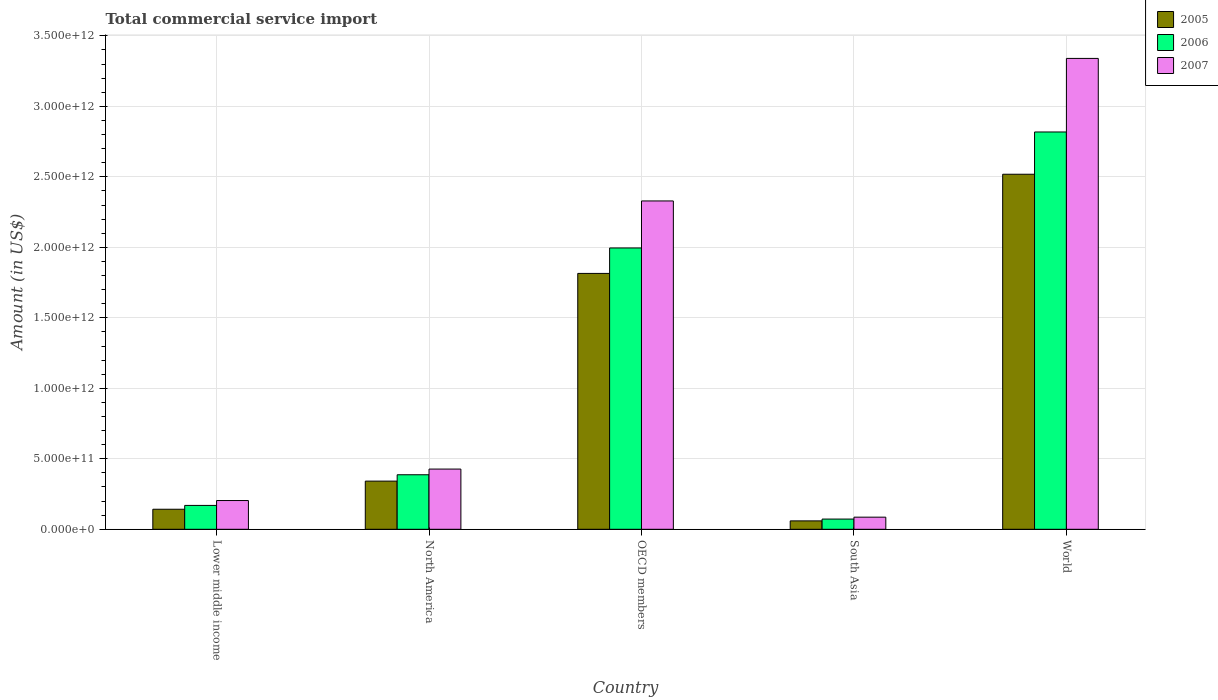Are the number of bars per tick equal to the number of legend labels?
Your response must be concise. Yes. How many bars are there on the 2nd tick from the left?
Give a very brief answer. 3. How many bars are there on the 1st tick from the right?
Offer a terse response. 3. What is the label of the 3rd group of bars from the left?
Ensure brevity in your answer.  OECD members. What is the total commercial service import in 2006 in South Asia?
Provide a short and direct response. 7.25e+1. Across all countries, what is the maximum total commercial service import in 2006?
Your response must be concise. 2.82e+12. Across all countries, what is the minimum total commercial service import in 2005?
Provide a succinct answer. 5.96e+1. What is the total total commercial service import in 2007 in the graph?
Your answer should be very brief. 6.39e+12. What is the difference between the total commercial service import in 2006 in Lower middle income and that in World?
Provide a short and direct response. -2.65e+12. What is the difference between the total commercial service import in 2006 in North America and the total commercial service import in 2005 in Lower middle income?
Offer a very short reply. 2.45e+11. What is the average total commercial service import in 2007 per country?
Offer a very short reply. 1.28e+12. What is the difference between the total commercial service import of/in 2005 and total commercial service import of/in 2007 in World?
Provide a succinct answer. -8.22e+11. In how many countries, is the total commercial service import in 2005 greater than 1300000000000 US$?
Your answer should be compact. 2. What is the ratio of the total commercial service import in 2006 in Lower middle income to that in World?
Your answer should be compact. 0.06. What is the difference between the highest and the second highest total commercial service import in 2006?
Your answer should be compact. 8.23e+11. What is the difference between the highest and the lowest total commercial service import in 2007?
Offer a very short reply. 3.25e+12. What does the 1st bar from the left in Lower middle income represents?
Your answer should be very brief. 2005. Is it the case that in every country, the sum of the total commercial service import in 2005 and total commercial service import in 2007 is greater than the total commercial service import in 2006?
Make the answer very short. Yes. What is the difference between two consecutive major ticks on the Y-axis?
Your response must be concise. 5.00e+11. Does the graph contain grids?
Ensure brevity in your answer.  Yes. How are the legend labels stacked?
Provide a short and direct response. Vertical. What is the title of the graph?
Offer a very short reply. Total commercial service import. Does "1996" appear as one of the legend labels in the graph?
Your response must be concise. No. What is the label or title of the Y-axis?
Offer a terse response. Amount (in US$). What is the Amount (in US$) of 2005 in Lower middle income?
Your answer should be very brief. 1.42e+11. What is the Amount (in US$) in 2006 in Lower middle income?
Make the answer very short. 1.69e+11. What is the Amount (in US$) in 2007 in Lower middle income?
Your answer should be compact. 2.04e+11. What is the Amount (in US$) in 2005 in North America?
Provide a short and direct response. 3.42e+11. What is the Amount (in US$) in 2006 in North America?
Keep it short and to the point. 3.87e+11. What is the Amount (in US$) of 2007 in North America?
Your response must be concise. 4.27e+11. What is the Amount (in US$) in 2005 in OECD members?
Offer a very short reply. 1.81e+12. What is the Amount (in US$) of 2006 in OECD members?
Offer a very short reply. 2.00e+12. What is the Amount (in US$) of 2007 in OECD members?
Offer a terse response. 2.33e+12. What is the Amount (in US$) in 2005 in South Asia?
Your answer should be very brief. 5.96e+1. What is the Amount (in US$) in 2006 in South Asia?
Ensure brevity in your answer.  7.25e+1. What is the Amount (in US$) in 2007 in South Asia?
Ensure brevity in your answer.  8.60e+1. What is the Amount (in US$) in 2005 in World?
Offer a terse response. 2.52e+12. What is the Amount (in US$) of 2006 in World?
Provide a succinct answer. 2.82e+12. What is the Amount (in US$) of 2007 in World?
Provide a succinct answer. 3.34e+12. Across all countries, what is the maximum Amount (in US$) in 2005?
Your answer should be very brief. 2.52e+12. Across all countries, what is the maximum Amount (in US$) in 2006?
Keep it short and to the point. 2.82e+12. Across all countries, what is the maximum Amount (in US$) in 2007?
Offer a very short reply. 3.34e+12. Across all countries, what is the minimum Amount (in US$) of 2005?
Your answer should be compact. 5.96e+1. Across all countries, what is the minimum Amount (in US$) in 2006?
Your response must be concise. 7.25e+1. Across all countries, what is the minimum Amount (in US$) of 2007?
Offer a terse response. 8.60e+1. What is the total Amount (in US$) in 2005 in the graph?
Keep it short and to the point. 4.88e+12. What is the total Amount (in US$) of 2006 in the graph?
Your answer should be compact. 5.44e+12. What is the total Amount (in US$) in 2007 in the graph?
Your answer should be very brief. 6.39e+12. What is the difference between the Amount (in US$) in 2005 in Lower middle income and that in North America?
Your answer should be compact. -1.99e+11. What is the difference between the Amount (in US$) of 2006 in Lower middle income and that in North America?
Ensure brevity in your answer.  -2.17e+11. What is the difference between the Amount (in US$) of 2007 in Lower middle income and that in North America?
Offer a terse response. -2.23e+11. What is the difference between the Amount (in US$) in 2005 in Lower middle income and that in OECD members?
Provide a succinct answer. -1.67e+12. What is the difference between the Amount (in US$) in 2006 in Lower middle income and that in OECD members?
Provide a succinct answer. -1.83e+12. What is the difference between the Amount (in US$) in 2007 in Lower middle income and that in OECD members?
Provide a short and direct response. -2.12e+12. What is the difference between the Amount (in US$) in 2005 in Lower middle income and that in South Asia?
Make the answer very short. 8.26e+1. What is the difference between the Amount (in US$) in 2006 in Lower middle income and that in South Asia?
Ensure brevity in your answer.  9.68e+1. What is the difference between the Amount (in US$) of 2007 in Lower middle income and that in South Asia?
Offer a very short reply. 1.18e+11. What is the difference between the Amount (in US$) of 2005 in Lower middle income and that in World?
Provide a succinct answer. -2.38e+12. What is the difference between the Amount (in US$) of 2006 in Lower middle income and that in World?
Your answer should be very brief. -2.65e+12. What is the difference between the Amount (in US$) of 2007 in Lower middle income and that in World?
Keep it short and to the point. -3.14e+12. What is the difference between the Amount (in US$) of 2005 in North America and that in OECD members?
Your answer should be very brief. -1.47e+12. What is the difference between the Amount (in US$) of 2006 in North America and that in OECD members?
Ensure brevity in your answer.  -1.61e+12. What is the difference between the Amount (in US$) in 2007 in North America and that in OECD members?
Provide a short and direct response. -1.90e+12. What is the difference between the Amount (in US$) of 2005 in North America and that in South Asia?
Your answer should be compact. 2.82e+11. What is the difference between the Amount (in US$) of 2006 in North America and that in South Asia?
Offer a very short reply. 3.14e+11. What is the difference between the Amount (in US$) in 2007 in North America and that in South Asia?
Your response must be concise. 3.41e+11. What is the difference between the Amount (in US$) in 2005 in North America and that in World?
Provide a short and direct response. -2.18e+12. What is the difference between the Amount (in US$) of 2006 in North America and that in World?
Provide a short and direct response. -2.43e+12. What is the difference between the Amount (in US$) in 2007 in North America and that in World?
Your response must be concise. -2.91e+12. What is the difference between the Amount (in US$) in 2005 in OECD members and that in South Asia?
Make the answer very short. 1.76e+12. What is the difference between the Amount (in US$) in 2006 in OECD members and that in South Asia?
Provide a succinct answer. 1.92e+12. What is the difference between the Amount (in US$) in 2007 in OECD members and that in South Asia?
Keep it short and to the point. 2.24e+12. What is the difference between the Amount (in US$) of 2005 in OECD members and that in World?
Your answer should be compact. -7.03e+11. What is the difference between the Amount (in US$) of 2006 in OECD members and that in World?
Offer a terse response. -8.23e+11. What is the difference between the Amount (in US$) in 2007 in OECD members and that in World?
Give a very brief answer. -1.01e+12. What is the difference between the Amount (in US$) in 2005 in South Asia and that in World?
Your response must be concise. -2.46e+12. What is the difference between the Amount (in US$) of 2006 in South Asia and that in World?
Your response must be concise. -2.75e+12. What is the difference between the Amount (in US$) of 2007 in South Asia and that in World?
Your answer should be very brief. -3.25e+12. What is the difference between the Amount (in US$) in 2005 in Lower middle income and the Amount (in US$) in 2006 in North America?
Ensure brevity in your answer.  -2.45e+11. What is the difference between the Amount (in US$) in 2005 in Lower middle income and the Amount (in US$) in 2007 in North America?
Your response must be concise. -2.85e+11. What is the difference between the Amount (in US$) of 2006 in Lower middle income and the Amount (in US$) of 2007 in North America?
Your response must be concise. -2.58e+11. What is the difference between the Amount (in US$) in 2005 in Lower middle income and the Amount (in US$) in 2006 in OECD members?
Ensure brevity in your answer.  -1.85e+12. What is the difference between the Amount (in US$) in 2005 in Lower middle income and the Amount (in US$) in 2007 in OECD members?
Make the answer very short. -2.19e+12. What is the difference between the Amount (in US$) in 2006 in Lower middle income and the Amount (in US$) in 2007 in OECD members?
Ensure brevity in your answer.  -2.16e+12. What is the difference between the Amount (in US$) in 2005 in Lower middle income and the Amount (in US$) in 2006 in South Asia?
Ensure brevity in your answer.  6.97e+1. What is the difference between the Amount (in US$) of 2005 in Lower middle income and the Amount (in US$) of 2007 in South Asia?
Give a very brief answer. 5.62e+1. What is the difference between the Amount (in US$) of 2006 in Lower middle income and the Amount (in US$) of 2007 in South Asia?
Your response must be concise. 8.33e+1. What is the difference between the Amount (in US$) in 2005 in Lower middle income and the Amount (in US$) in 2006 in World?
Provide a short and direct response. -2.68e+12. What is the difference between the Amount (in US$) of 2005 in Lower middle income and the Amount (in US$) of 2007 in World?
Ensure brevity in your answer.  -3.20e+12. What is the difference between the Amount (in US$) of 2006 in Lower middle income and the Amount (in US$) of 2007 in World?
Offer a terse response. -3.17e+12. What is the difference between the Amount (in US$) in 2005 in North America and the Amount (in US$) in 2006 in OECD members?
Give a very brief answer. -1.65e+12. What is the difference between the Amount (in US$) of 2005 in North America and the Amount (in US$) of 2007 in OECD members?
Provide a succinct answer. -1.99e+12. What is the difference between the Amount (in US$) in 2006 in North America and the Amount (in US$) in 2007 in OECD members?
Ensure brevity in your answer.  -1.94e+12. What is the difference between the Amount (in US$) in 2005 in North America and the Amount (in US$) in 2006 in South Asia?
Keep it short and to the point. 2.69e+11. What is the difference between the Amount (in US$) in 2005 in North America and the Amount (in US$) in 2007 in South Asia?
Keep it short and to the point. 2.56e+11. What is the difference between the Amount (in US$) in 2006 in North America and the Amount (in US$) in 2007 in South Asia?
Your answer should be very brief. 3.01e+11. What is the difference between the Amount (in US$) in 2005 in North America and the Amount (in US$) in 2006 in World?
Your response must be concise. -2.48e+12. What is the difference between the Amount (in US$) in 2005 in North America and the Amount (in US$) in 2007 in World?
Offer a terse response. -3.00e+12. What is the difference between the Amount (in US$) of 2006 in North America and the Amount (in US$) of 2007 in World?
Make the answer very short. -2.95e+12. What is the difference between the Amount (in US$) of 2005 in OECD members and the Amount (in US$) of 2006 in South Asia?
Provide a short and direct response. 1.74e+12. What is the difference between the Amount (in US$) in 2005 in OECD members and the Amount (in US$) in 2007 in South Asia?
Offer a very short reply. 1.73e+12. What is the difference between the Amount (in US$) of 2006 in OECD members and the Amount (in US$) of 2007 in South Asia?
Your answer should be very brief. 1.91e+12. What is the difference between the Amount (in US$) of 2005 in OECD members and the Amount (in US$) of 2006 in World?
Provide a succinct answer. -1.00e+12. What is the difference between the Amount (in US$) in 2005 in OECD members and the Amount (in US$) in 2007 in World?
Your answer should be very brief. -1.52e+12. What is the difference between the Amount (in US$) of 2006 in OECD members and the Amount (in US$) of 2007 in World?
Your answer should be very brief. -1.34e+12. What is the difference between the Amount (in US$) in 2005 in South Asia and the Amount (in US$) in 2006 in World?
Provide a short and direct response. -2.76e+12. What is the difference between the Amount (in US$) in 2005 in South Asia and the Amount (in US$) in 2007 in World?
Your answer should be compact. -3.28e+12. What is the difference between the Amount (in US$) in 2006 in South Asia and the Amount (in US$) in 2007 in World?
Offer a terse response. -3.27e+12. What is the average Amount (in US$) in 2005 per country?
Make the answer very short. 9.75e+11. What is the average Amount (in US$) in 2006 per country?
Provide a succinct answer. 1.09e+12. What is the average Amount (in US$) in 2007 per country?
Ensure brevity in your answer.  1.28e+12. What is the difference between the Amount (in US$) in 2005 and Amount (in US$) in 2006 in Lower middle income?
Provide a succinct answer. -2.71e+1. What is the difference between the Amount (in US$) in 2005 and Amount (in US$) in 2007 in Lower middle income?
Your response must be concise. -6.17e+1. What is the difference between the Amount (in US$) of 2006 and Amount (in US$) of 2007 in Lower middle income?
Your answer should be very brief. -3.46e+1. What is the difference between the Amount (in US$) in 2005 and Amount (in US$) in 2006 in North America?
Your response must be concise. -4.52e+1. What is the difference between the Amount (in US$) in 2005 and Amount (in US$) in 2007 in North America?
Your answer should be very brief. -8.54e+1. What is the difference between the Amount (in US$) of 2006 and Amount (in US$) of 2007 in North America?
Offer a very short reply. -4.02e+1. What is the difference between the Amount (in US$) of 2005 and Amount (in US$) of 2006 in OECD members?
Provide a succinct answer. -1.80e+11. What is the difference between the Amount (in US$) in 2005 and Amount (in US$) in 2007 in OECD members?
Provide a short and direct response. -5.14e+11. What is the difference between the Amount (in US$) of 2006 and Amount (in US$) of 2007 in OECD members?
Your answer should be very brief. -3.34e+11. What is the difference between the Amount (in US$) in 2005 and Amount (in US$) in 2006 in South Asia?
Provide a succinct answer. -1.29e+1. What is the difference between the Amount (in US$) of 2005 and Amount (in US$) of 2007 in South Asia?
Ensure brevity in your answer.  -2.64e+1. What is the difference between the Amount (in US$) in 2006 and Amount (in US$) in 2007 in South Asia?
Make the answer very short. -1.35e+1. What is the difference between the Amount (in US$) of 2005 and Amount (in US$) of 2006 in World?
Offer a very short reply. -3.00e+11. What is the difference between the Amount (in US$) of 2005 and Amount (in US$) of 2007 in World?
Your answer should be very brief. -8.22e+11. What is the difference between the Amount (in US$) of 2006 and Amount (in US$) of 2007 in World?
Your answer should be very brief. -5.22e+11. What is the ratio of the Amount (in US$) in 2005 in Lower middle income to that in North America?
Your answer should be very brief. 0.42. What is the ratio of the Amount (in US$) in 2006 in Lower middle income to that in North America?
Your answer should be compact. 0.44. What is the ratio of the Amount (in US$) of 2007 in Lower middle income to that in North America?
Ensure brevity in your answer.  0.48. What is the ratio of the Amount (in US$) of 2005 in Lower middle income to that in OECD members?
Provide a short and direct response. 0.08. What is the ratio of the Amount (in US$) of 2006 in Lower middle income to that in OECD members?
Ensure brevity in your answer.  0.08. What is the ratio of the Amount (in US$) in 2007 in Lower middle income to that in OECD members?
Your answer should be compact. 0.09. What is the ratio of the Amount (in US$) in 2005 in Lower middle income to that in South Asia?
Give a very brief answer. 2.38. What is the ratio of the Amount (in US$) in 2006 in Lower middle income to that in South Asia?
Provide a succinct answer. 2.34. What is the ratio of the Amount (in US$) in 2007 in Lower middle income to that in South Asia?
Your answer should be very brief. 2.37. What is the ratio of the Amount (in US$) in 2005 in Lower middle income to that in World?
Your answer should be very brief. 0.06. What is the ratio of the Amount (in US$) of 2006 in Lower middle income to that in World?
Offer a terse response. 0.06. What is the ratio of the Amount (in US$) of 2007 in Lower middle income to that in World?
Offer a terse response. 0.06. What is the ratio of the Amount (in US$) in 2005 in North America to that in OECD members?
Your response must be concise. 0.19. What is the ratio of the Amount (in US$) in 2006 in North America to that in OECD members?
Your answer should be very brief. 0.19. What is the ratio of the Amount (in US$) of 2007 in North America to that in OECD members?
Give a very brief answer. 0.18. What is the ratio of the Amount (in US$) of 2005 in North America to that in South Asia?
Your response must be concise. 5.73. What is the ratio of the Amount (in US$) of 2006 in North America to that in South Asia?
Offer a terse response. 5.33. What is the ratio of the Amount (in US$) in 2007 in North America to that in South Asia?
Make the answer very short. 4.97. What is the ratio of the Amount (in US$) of 2005 in North America to that in World?
Make the answer very short. 0.14. What is the ratio of the Amount (in US$) in 2006 in North America to that in World?
Keep it short and to the point. 0.14. What is the ratio of the Amount (in US$) in 2007 in North America to that in World?
Your answer should be very brief. 0.13. What is the ratio of the Amount (in US$) of 2005 in OECD members to that in South Asia?
Ensure brevity in your answer.  30.43. What is the ratio of the Amount (in US$) in 2006 in OECD members to that in South Asia?
Offer a very short reply. 27.52. What is the ratio of the Amount (in US$) of 2007 in OECD members to that in South Asia?
Your answer should be compact. 27.08. What is the ratio of the Amount (in US$) in 2005 in OECD members to that in World?
Offer a terse response. 0.72. What is the ratio of the Amount (in US$) in 2006 in OECD members to that in World?
Your answer should be very brief. 0.71. What is the ratio of the Amount (in US$) of 2007 in OECD members to that in World?
Provide a succinct answer. 0.7. What is the ratio of the Amount (in US$) in 2005 in South Asia to that in World?
Offer a terse response. 0.02. What is the ratio of the Amount (in US$) in 2006 in South Asia to that in World?
Give a very brief answer. 0.03. What is the ratio of the Amount (in US$) of 2007 in South Asia to that in World?
Your answer should be compact. 0.03. What is the difference between the highest and the second highest Amount (in US$) in 2005?
Give a very brief answer. 7.03e+11. What is the difference between the highest and the second highest Amount (in US$) of 2006?
Keep it short and to the point. 8.23e+11. What is the difference between the highest and the second highest Amount (in US$) in 2007?
Keep it short and to the point. 1.01e+12. What is the difference between the highest and the lowest Amount (in US$) of 2005?
Make the answer very short. 2.46e+12. What is the difference between the highest and the lowest Amount (in US$) in 2006?
Keep it short and to the point. 2.75e+12. What is the difference between the highest and the lowest Amount (in US$) of 2007?
Your answer should be very brief. 3.25e+12. 